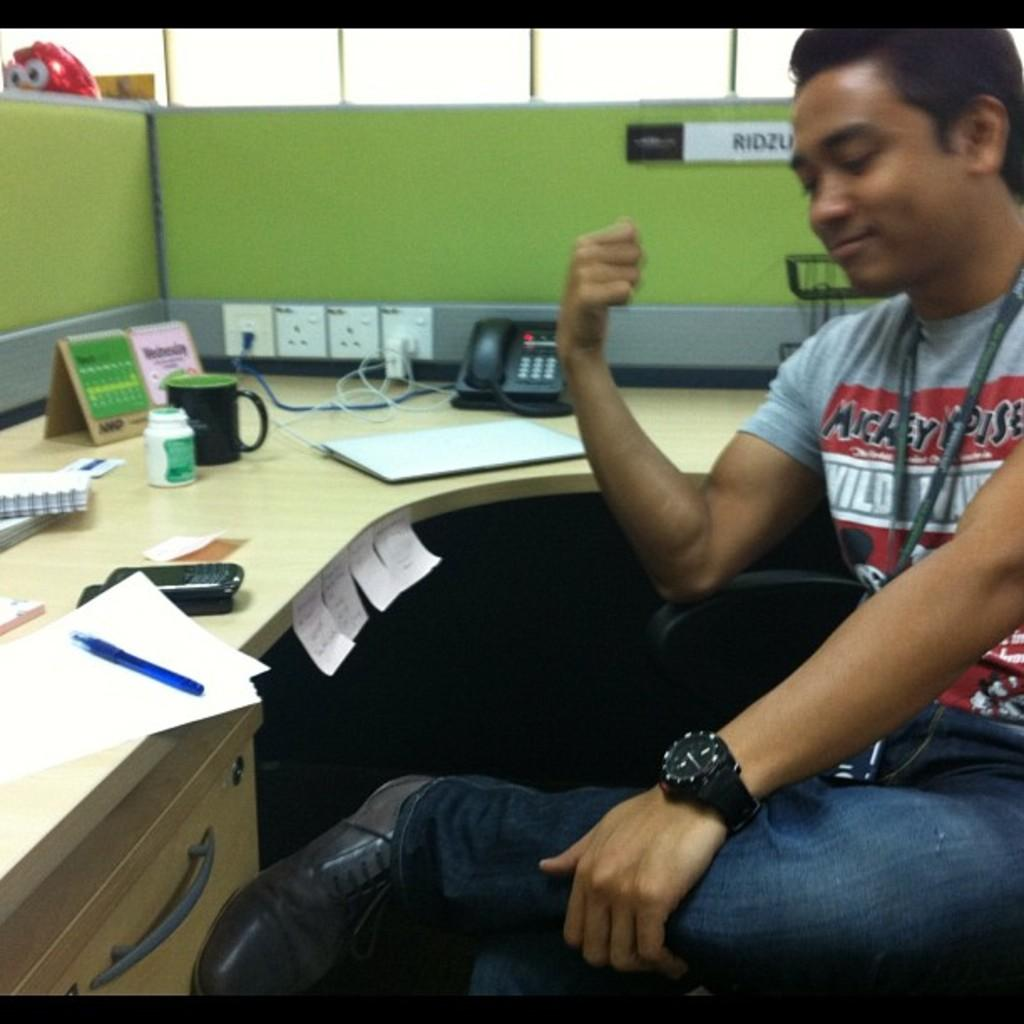What is the man in the image doing? The man is sitting on a chair in the image. What is located on the table in the image? There is a mobile, papers, a cup, and a telephone on the table in the image. Can you describe the objects on the table in more detail? The mobile is likely a decorative item, the papers could be documents or notes, the cup is likely for holding a beverage, and the telephone is a device for communication. What type of rhythm can be heard coming from the street in the image? There is no street or rhythm present in the image; it features a man sitting on a chair and objects on a table. 